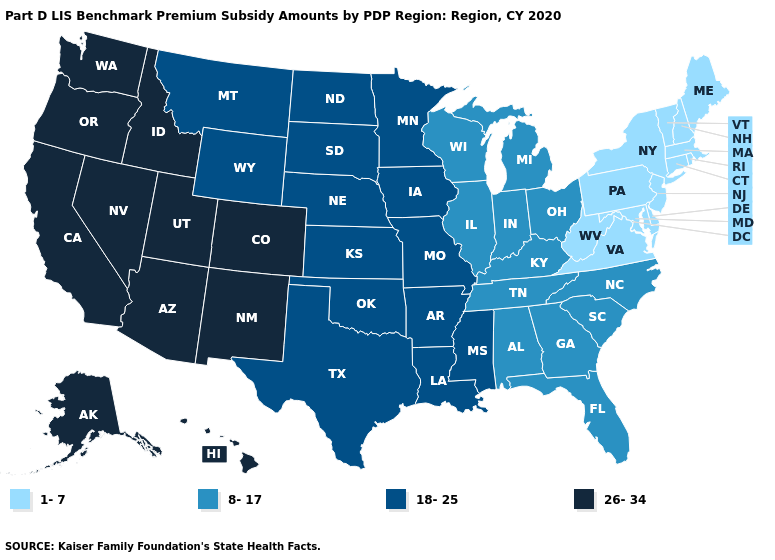What is the value of Nevada?
Give a very brief answer. 26-34. What is the value of Mississippi?
Short answer required. 18-25. Name the states that have a value in the range 18-25?
Be succinct. Arkansas, Iowa, Kansas, Louisiana, Minnesota, Mississippi, Missouri, Montana, Nebraska, North Dakota, Oklahoma, South Dakota, Texas, Wyoming. Among the states that border Minnesota , which have the lowest value?
Be succinct. Wisconsin. Name the states that have a value in the range 18-25?
Write a very short answer. Arkansas, Iowa, Kansas, Louisiana, Minnesota, Mississippi, Missouri, Montana, Nebraska, North Dakota, Oklahoma, South Dakota, Texas, Wyoming. What is the lowest value in the USA?
Give a very brief answer. 1-7. What is the value of Missouri?
Write a very short answer. 18-25. Name the states that have a value in the range 1-7?
Answer briefly. Connecticut, Delaware, Maine, Maryland, Massachusetts, New Hampshire, New Jersey, New York, Pennsylvania, Rhode Island, Vermont, Virginia, West Virginia. Name the states that have a value in the range 18-25?
Give a very brief answer. Arkansas, Iowa, Kansas, Louisiana, Minnesota, Mississippi, Missouri, Montana, Nebraska, North Dakota, Oklahoma, South Dakota, Texas, Wyoming. Name the states that have a value in the range 18-25?
Give a very brief answer. Arkansas, Iowa, Kansas, Louisiana, Minnesota, Mississippi, Missouri, Montana, Nebraska, North Dakota, Oklahoma, South Dakota, Texas, Wyoming. What is the highest value in the USA?
Concise answer only. 26-34. Name the states that have a value in the range 1-7?
Keep it brief. Connecticut, Delaware, Maine, Maryland, Massachusetts, New Hampshire, New Jersey, New York, Pennsylvania, Rhode Island, Vermont, Virginia, West Virginia. What is the lowest value in the South?
Short answer required. 1-7. Does the first symbol in the legend represent the smallest category?
Write a very short answer. Yes. Name the states that have a value in the range 18-25?
Short answer required. Arkansas, Iowa, Kansas, Louisiana, Minnesota, Mississippi, Missouri, Montana, Nebraska, North Dakota, Oklahoma, South Dakota, Texas, Wyoming. 